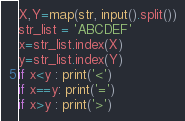<code> <loc_0><loc_0><loc_500><loc_500><_Python_>X,Y=map(str, input().split())
str_list = 'ABCDEF'
x=str_list.index(X)
y=str_list.index(Y)
if x<y : print('<')
if x==y: print('=')
if x>y : print('>')
</code> 